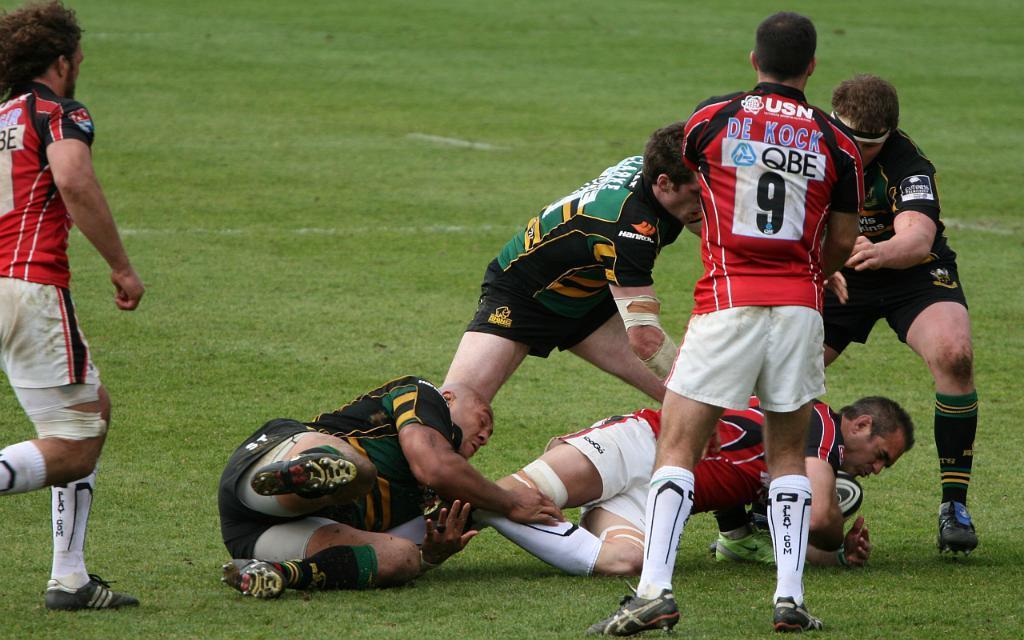How would you summarize this image in a sentence or two? In the front of the image there are people. Land is covered with grass. Among them one person is holding a ball.   